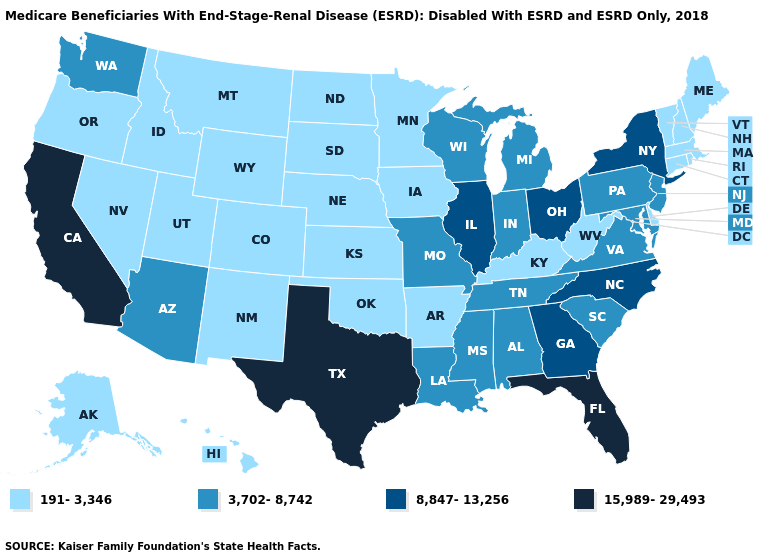Name the states that have a value in the range 8,847-13,256?
Short answer required. Georgia, Illinois, New York, North Carolina, Ohio. What is the value of Oregon?
Write a very short answer. 191-3,346. What is the value of New Hampshire?
Give a very brief answer. 191-3,346. Name the states that have a value in the range 15,989-29,493?
Concise answer only. California, Florida, Texas. Name the states that have a value in the range 191-3,346?
Short answer required. Alaska, Arkansas, Colorado, Connecticut, Delaware, Hawaii, Idaho, Iowa, Kansas, Kentucky, Maine, Massachusetts, Minnesota, Montana, Nebraska, Nevada, New Hampshire, New Mexico, North Dakota, Oklahoma, Oregon, Rhode Island, South Dakota, Utah, Vermont, West Virginia, Wyoming. Name the states that have a value in the range 3,702-8,742?
Write a very short answer. Alabama, Arizona, Indiana, Louisiana, Maryland, Michigan, Mississippi, Missouri, New Jersey, Pennsylvania, South Carolina, Tennessee, Virginia, Washington, Wisconsin. Name the states that have a value in the range 8,847-13,256?
Write a very short answer. Georgia, Illinois, New York, North Carolina, Ohio. Does Montana have a lower value than Delaware?
Write a very short answer. No. Name the states that have a value in the range 191-3,346?
Answer briefly. Alaska, Arkansas, Colorado, Connecticut, Delaware, Hawaii, Idaho, Iowa, Kansas, Kentucky, Maine, Massachusetts, Minnesota, Montana, Nebraska, Nevada, New Hampshire, New Mexico, North Dakota, Oklahoma, Oregon, Rhode Island, South Dakota, Utah, Vermont, West Virginia, Wyoming. What is the lowest value in the West?
Quick response, please. 191-3,346. Among the states that border Connecticut , does Massachusetts have the highest value?
Write a very short answer. No. What is the value of Nevada?
Keep it brief. 191-3,346. Name the states that have a value in the range 191-3,346?
Give a very brief answer. Alaska, Arkansas, Colorado, Connecticut, Delaware, Hawaii, Idaho, Iowa, Kansas, Kentucky, Maine, Massachusetts, Minnesota, Montana, Nebraska, Nevada, New Hampshire, New Mexico, North Dakota, Oklahoma, Oregon, Rhode Island, South Dakota, Utah, Vermont, West Virginia, Wyoming. What is the value of Connecticut?
Short answer required. 191-3,346. 